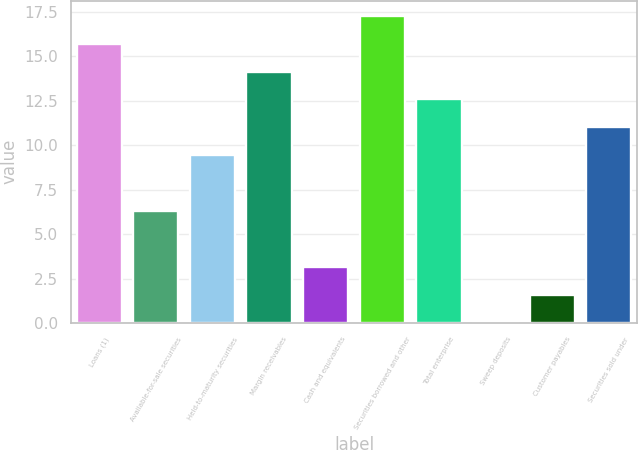Convert chart to OTSL. <chart><loc_0><loc_0><loc_500><loc_500><bar_chart><fcel>Loans (1)<fcel>Available-for-sale securities<fcel>Held-to-maturity securities<fcel>Margin receivables<fcel>Cash and equivalents<fcel>Securities borrowed and other<fcel>Total enterprise<fcel>Sweep deposits<fcel>Customer payables<fcel>Securities sold under<nl><fcel>15.7<fcel>6.31<fcel>9.45<fcel>14.13<fcel>3.17<fcel>17.27<fcel>12.57<fcel>0.03<fcel>1.6<fcel>11.01<nl></chart> 